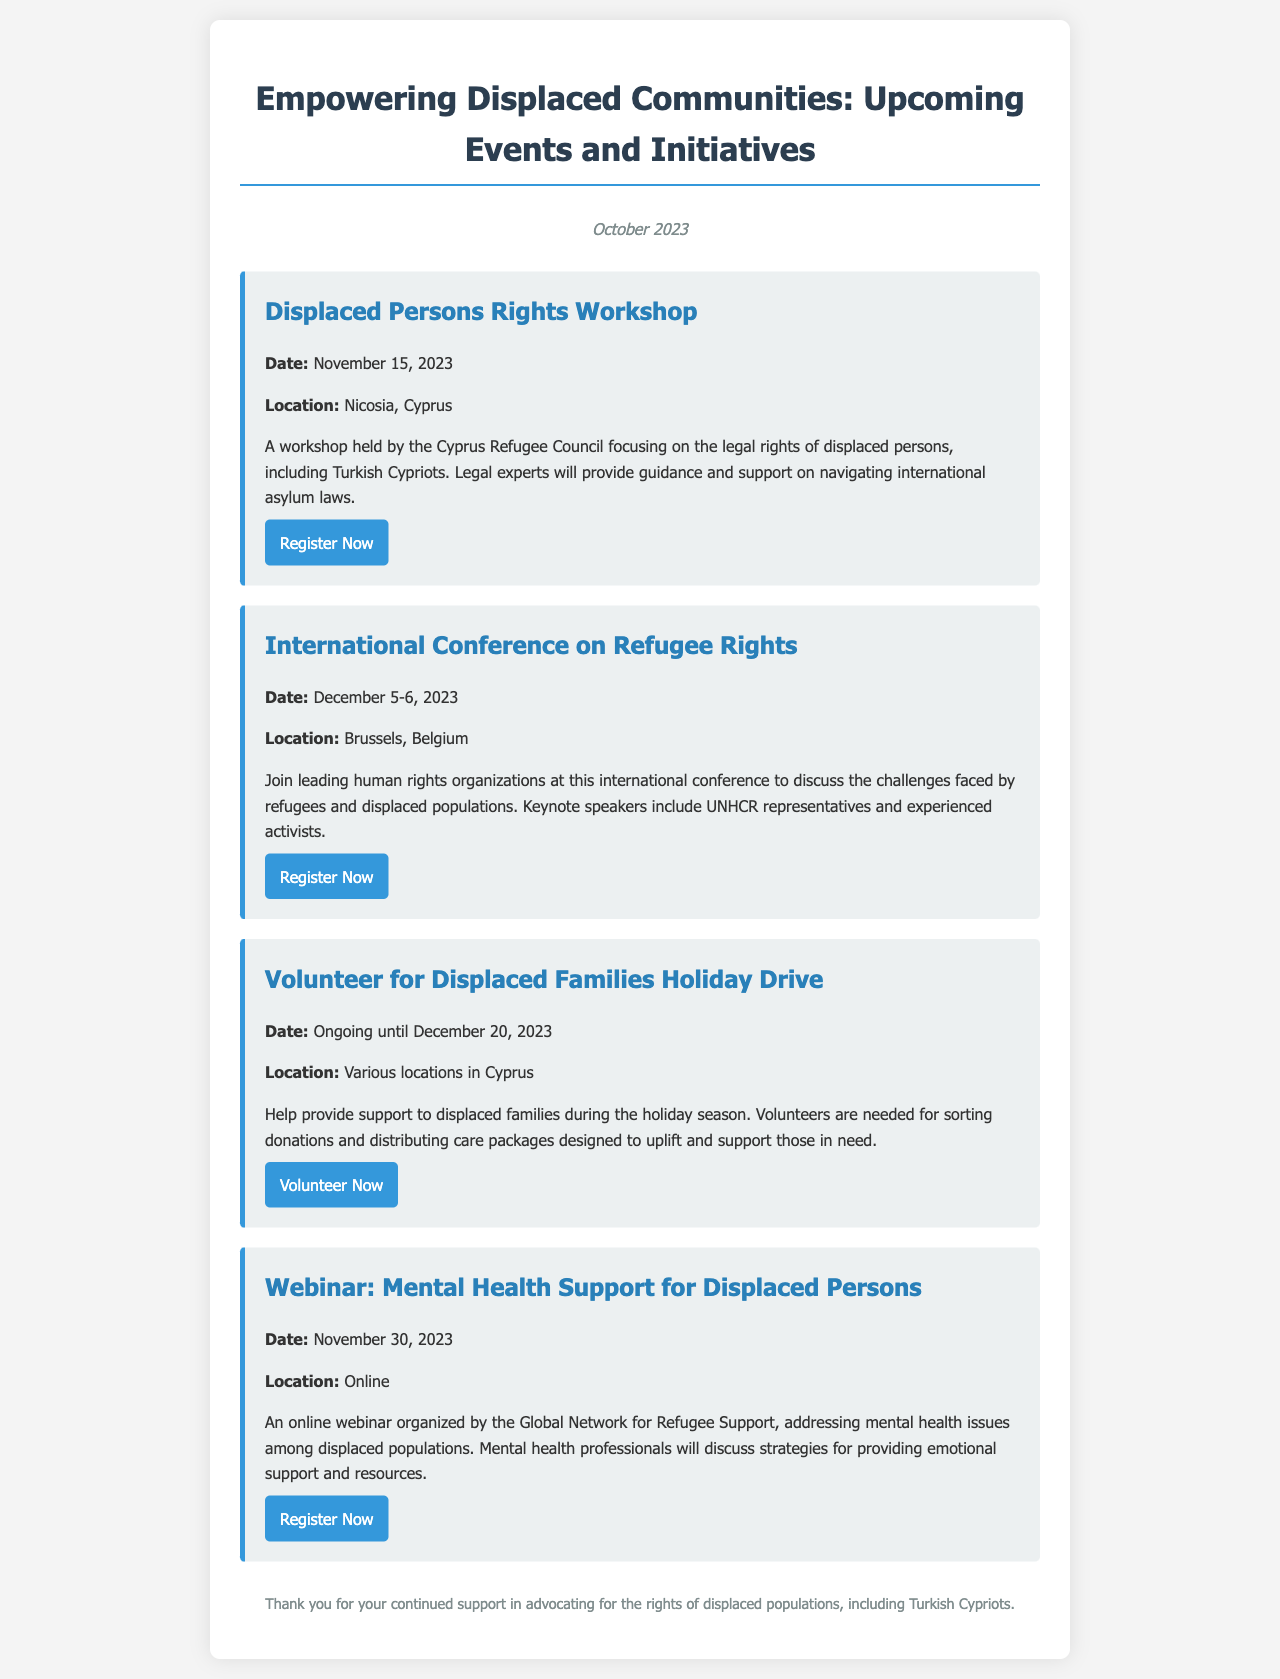What is the date of the Displaced Persons Rights Workshop? The document states that the Displaced Persons Rights Workshop is scheduled for November 15, 2023.
Answer: November 15, 2023 Where is the International Conference on Refugee Rights being held? The document indicates that the International Conference on Refugee Rights will take place in Brussels, Belgium.
Answer: Brussels, Belgium What ongoing initiative supports displaced families until December 20, 2023? According to the document, the Volunteer for Displaced Families Holiday Drive is the ongoing initiative supporting displaced families until December 20, 2023.
Answer: Volunteer for Displaced Families Holiday Drive Who is organizing the webinar on mental health support for displaced persons? The Global Network for Refugee Support is mentioned as the organizer of the webinar addressing mental health support for displaced persons.
Answer: Global Network for Refugee Support Which event has a registration link provided for the participant? The document contains registration links for multiple events, but specifically mentions the Displaced Persons Rights Workshop.
Answer: Displaced Persons Rights Workshop What is a key topic discussed in the upcoming webinars? The document reveals that the webinar will discuss mental health issues among displaced populations.
Answer: Mental health issues How many days will the International Conference on Refugee Rights last? The document states that the International Conference on Refugee Rights is scheduled for two days, from December 5-6, 2023.
Answer: Two days What is one requirement to participate in the Holiday Drive? The document specifies that volunteers are needed to sort donations and distribute care packages during the Holiday Drive.
Answer: Sorting donations What month is the newsletter issued? The newsletter states it is issued in October 2023.
Answer: October 2023 